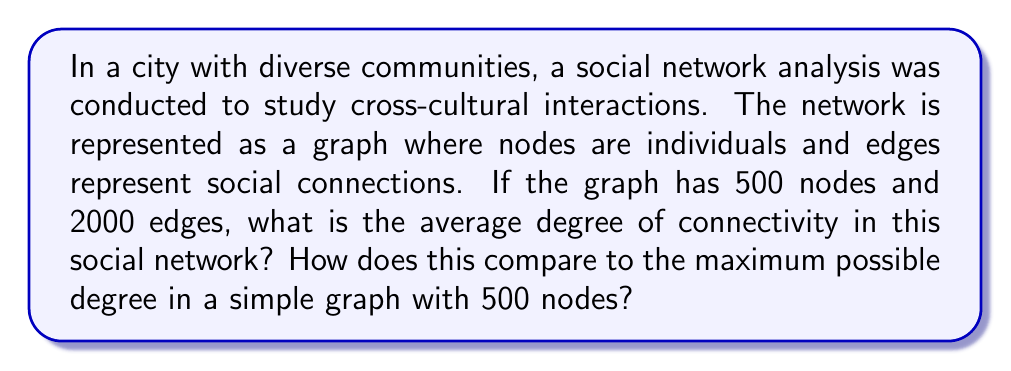Solve this math problem. To solve this problem, we need to understand a few key concepts in graph theory:

1. Degree: The degree of a node is the number of edges connected to it.
2. Average degree: The average number of connections per node in the graph.
3. Maximum degree: In a simple graph (no self-loops or multiple edges), the maximum degree is one less than the total number of nodes.

Step 1: Calculate the average degree

The average degree is calculated by dividing the total number of edge endpoints by the number of nodes. Since each edge has two endpoints, we multiply the number of edges by 2.

Average degree = $\frac{2 \times \text{number of edges}}{\text{number of nodes}}$

$$\text{Average degree} = \frac{2 \times 2000}{500} = \frac{4000}{500} = 8$$

Step 2: Determine the maximum possible degree

In a simple graph with 500 nodes, each node can potentially connect to all other nodes except itself. Therefore, the maximum possible degree is:

$$\text{Maximum degree} = 500 - 1 = 499$$

Step 3: Compare the average degree to the maximum possible degree

To express this as a percentage:

$$\text{Percentage} = \frac{\text{Average degree}}{\text{Maximum degree}} \times 100\%$$

$$\text{Percentage} = \frac{8}{499} \times 100\% \approx 1.60\%$$

This low percentage indicates that the social network is relatively sparse, with individuals connected to only a small fraction of the total population. This is typical in large-scale social networks, where people tend to have connections with a limited number of others relative to the total population size.
Answer: The average degree of connectivity in the social network is 8. This represents approximately 1.60% of the maximum possible degree (499) in a simple graph with 500 nodes. 